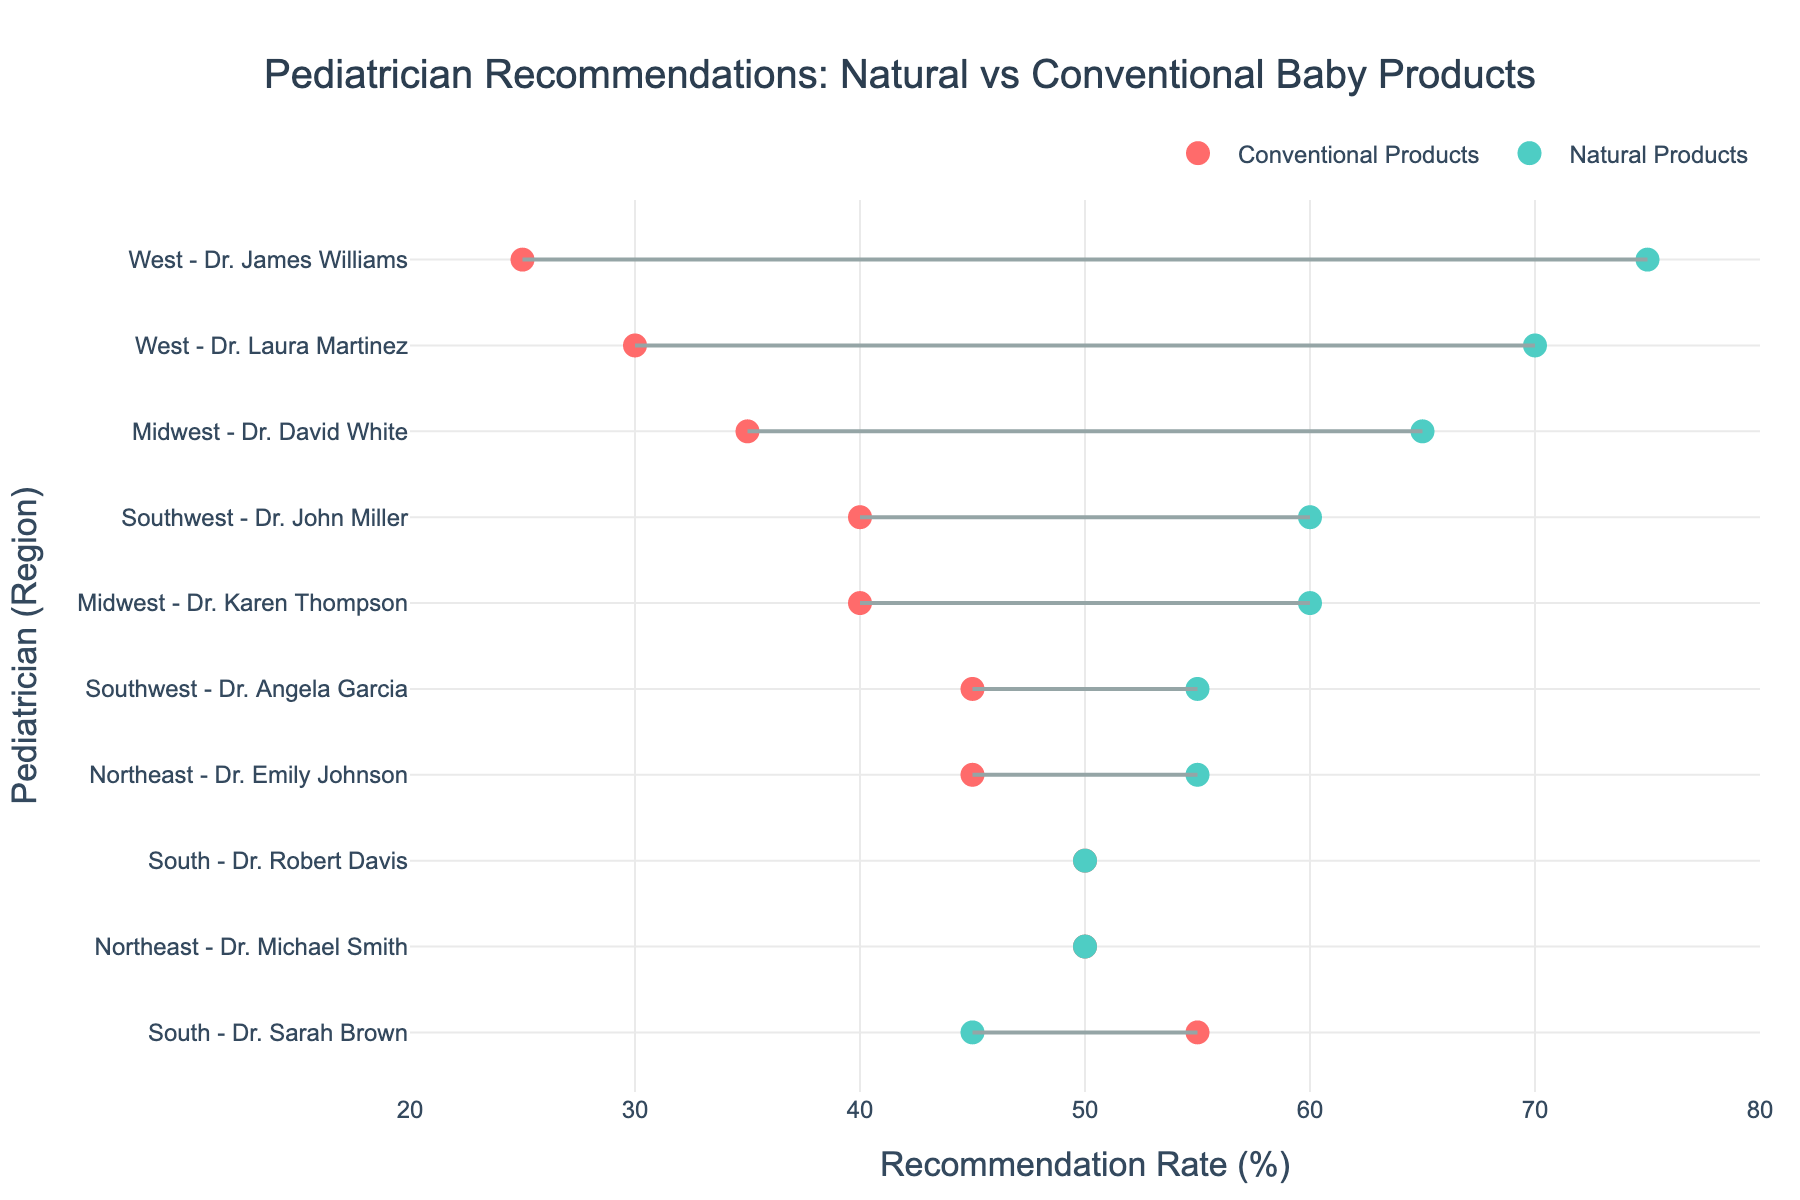what is the title of the plot? The title of the plot is usually displayed prominently at the top of the figure. In this case, it reads "Pediatrician Recommendations: Natural vs Conventional Baby Products".
Answer: Pediatrician Recommendations: Natural vs Conventional Baby Products Which pediatrician in the West recommends natural products the most? Look for pediatricians in the West region and compare their recommendation rates for natural products. Dr. James Williams has the highest recommendation rate for natural products in the West.
Answer: Dr. James Williams What is the recommendation rate for conventional products by Dr. Sarah Brown in the South region? Locate the data point for Dr. Sarah Brown in the South, then look at the recommendation rate for conventional products. The rate should be visible next to her name.
Answer: 55% How do the recommendation rates for natural products compare between the Northeast and Midwest regions? Summarize and compare the recommendation rates for pediatricians in both regions. In the Northeast, they are 55% and 50%, and in the Midwest, they are 60% and 65%. The rates in the Midwest are generally higher than in the Northeast.
Answer: Higher in the Midwest Which region has the most balance between natural and conventional product recommendations, based on the data? Compare the recommendation rates for natural vs. conventional products across regions and identify the region with the smallest difference between the two rates. The South has the most balanced rates, especially with Dr. Robert Davis showing a 50%-50% split.
Answer: South What is the average recommendation rate for natural products in the Southwest? Take the recommendation rates for natural products by pediatricians in the Southwest, which are 55% and 60%, add them together (55 + 60 = 115), and then divide by 2 to find the average (115 / 2 = 57.5).
Answer: 57.5% Which pediatrician has the largest difference in recommendation rates between natural and conventional products? Identify the pediatrician with the greatest disparity by subtracting the lower rate from the higher rate and compare across all pediatricians. Dr. James Williams has a difference of 50% (75% - 25%).
Answer: Dr. James Williams Is there any pediatrician who recommends conventional products more than natural products? Look for pediatricians whose rate of recommendations for conventional products is higher than that for natural products. Dr. Sarah Brown in the South has a higher rate for conventional products (55%) compared to natural products (45%).
Answer: Dr. Sarah Brown What is the range of recommendation rates for natural products across all pediatricians? Identify the lowest and highest recommendation rates for natural products across all pediatricians. The range is from a minimum of 45% to a maximum of 75%.
Answer: 45% to 75% 